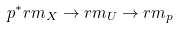Convert formula to latex. <formula><loc_0><loc_0><loc_500><loc_500>p ^ { * } \L r m _ { X } \rightarrow \L r m _ { U } \rightarrow \L r m _ { p }</formula> 